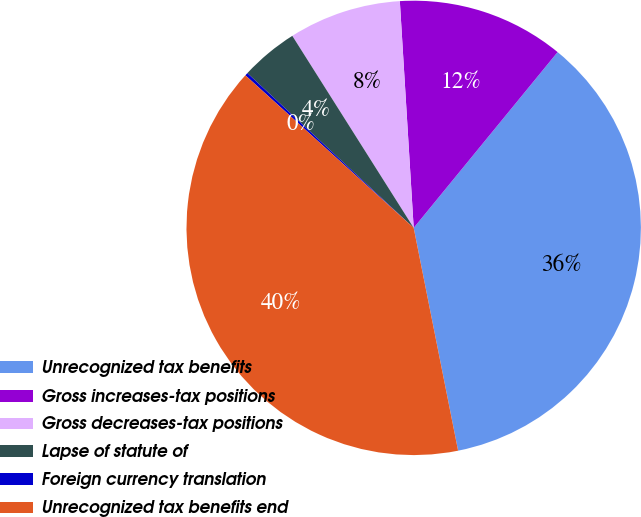Convert chart to OTSL. <chart><loc_0><loc_0><loc_500><loc_500><pie_chart><fcel>Unrecognized tax benefits<fcel>Gross increases-tax positions<fcel>Gross decreases-tax positions<fcel>Lapse of statute of<fcel>Foreign currency translation<fcel>Unrecognized tax benefits end<nl><fcel>35.95%<fcel>11.89%<fcel>8.0%<fcel>4.1%<fcel>0.21%<fcel>39.85%<nl></chart> 